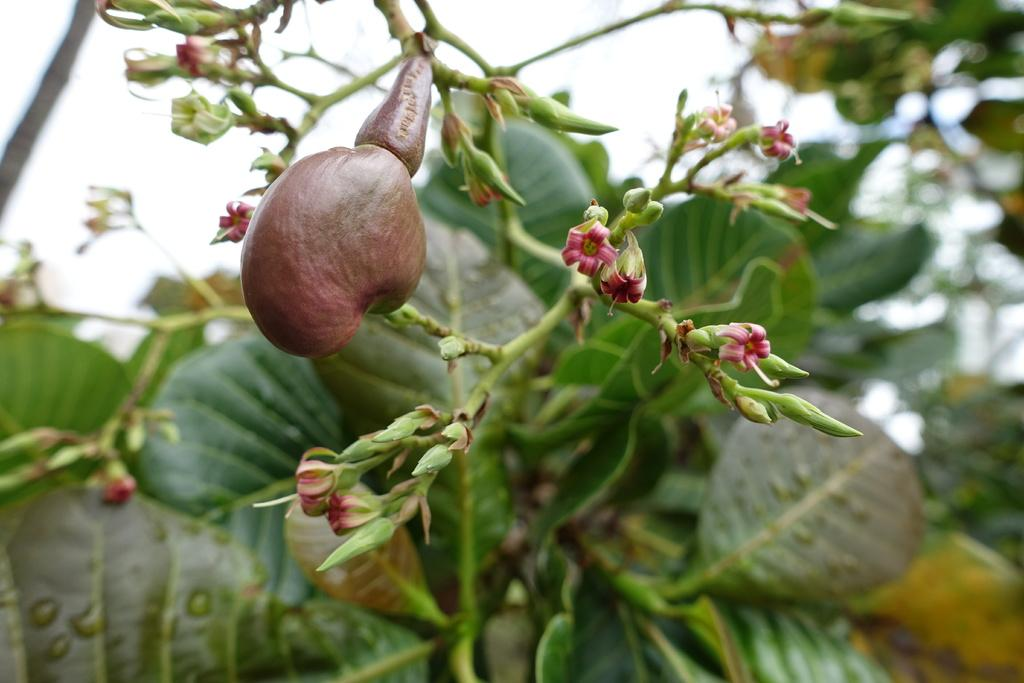What type of plant is in the image? There is a plant in the image, but the specific type cannot be determined from the facts provided. What features can be observed on the plant? The plant has flowers, buds, and fruit. What can be seen in the background of the image? There is greenery and the sky visible in the background of the image. What type of quartz can be seen in the image? There is no quartz present in the image. How many feet are visible in the image? There are no feet visible in the image. 